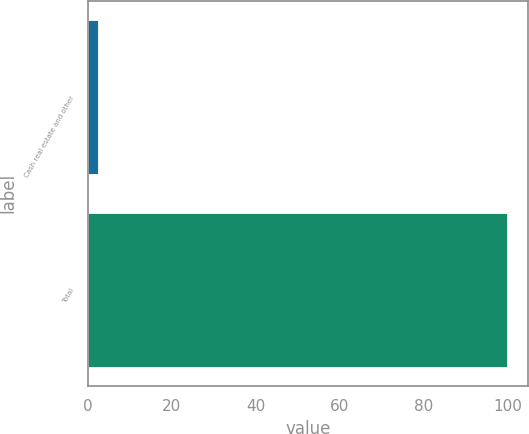<chart> <loc_0><loc_0><loc_500><loc_500><bar_chart><fcel>Cash real estate and other<fcel>Total<nl><fcel>2.32<fcel>100<nl></chart> 